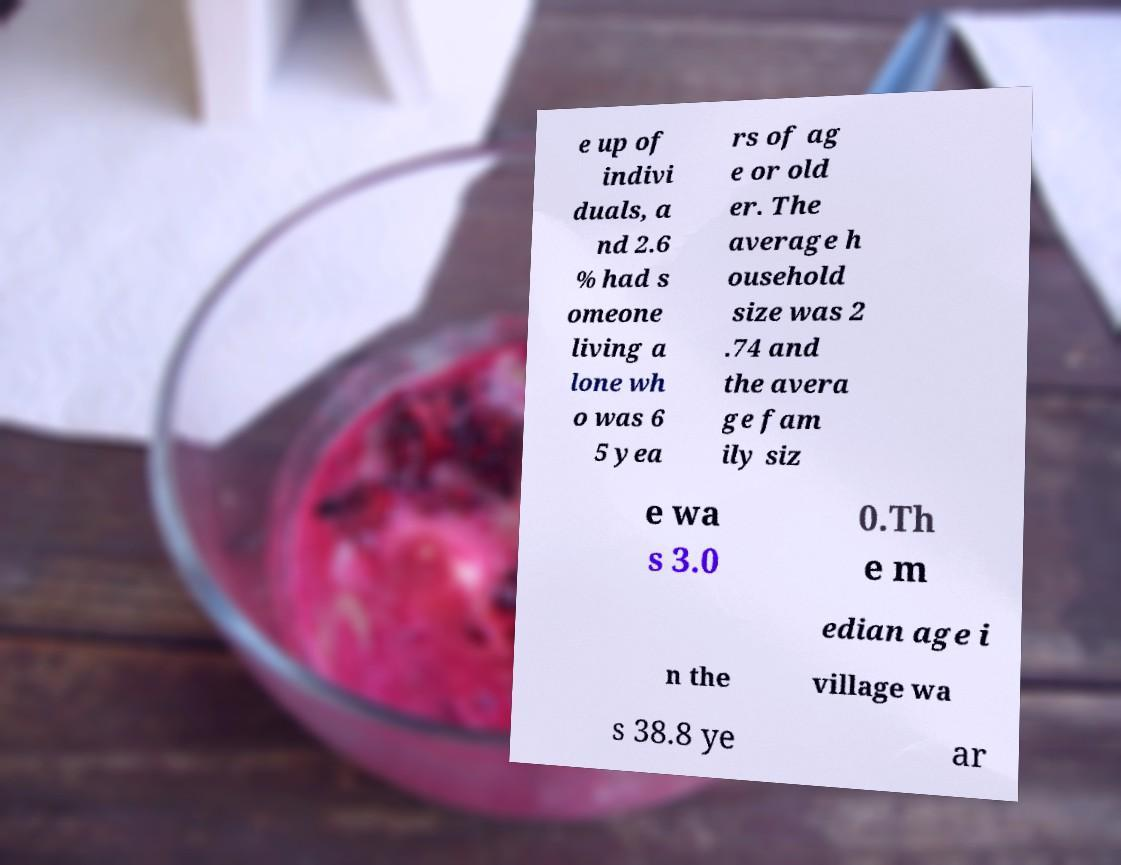There's text embedded in this image that I need extracted. Can you transcribe it verbatim? e up of indivi duals, a nd 2.6 % had s omeone living a lone wh o was 6 5 yea rs of ag e or old er. The average h ousehold size was 2 .74 and the avera ge fam ily siz e wa s 3.0 0.Th e m edian age i n the village wa s 38.8 ye ar 